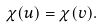<formula> <loc_0><loc_0><loc_500><loc_500>\chi ( u ) = \chi ( v ) .</formula> 